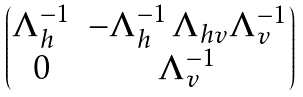Convert formula to latex. <formula><loc_0><loc_0><loc_500><loc_500>\begin{pmatrix} \Lambda _ { h } ^ { - 1 } & - \Lambda _ { h } ^ { - 1 } \, \Lambda _ { h v } \Lambda _ { v } ^ { - 1 } \\ 0 & \Lambda _ { v } ^ { - 1 } \end{pmatrix}</formula> 